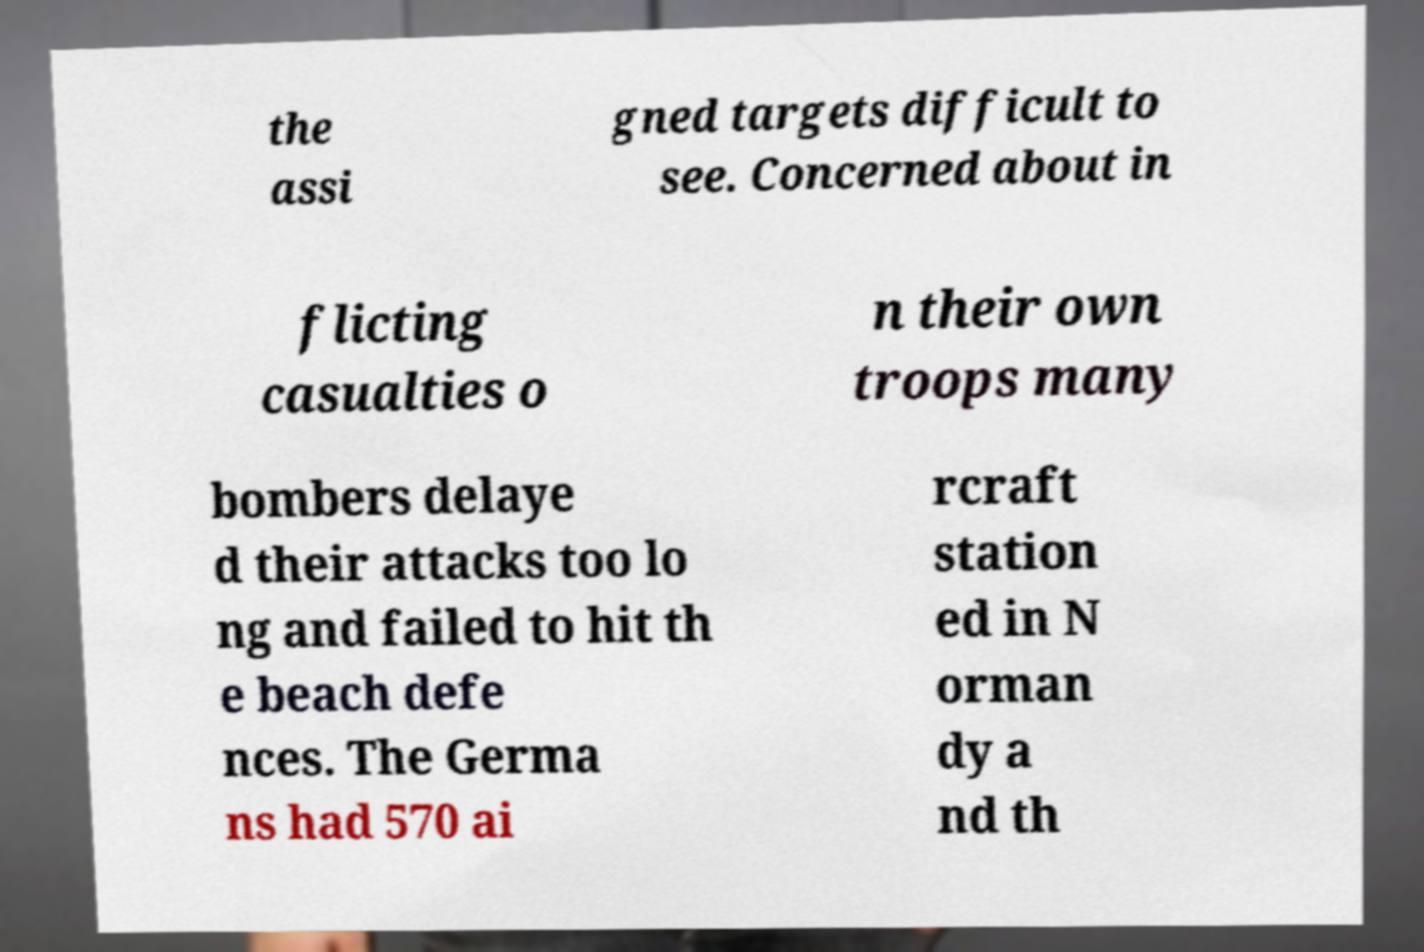Please identify and transcribe the text found in this image. the assi gned targets difficult to see. Concerned about in flicting casualties o n their own troops many bombers delaye d their attacks too lo ng and failed to hit th e beach defe nces. The Germa ns had 570 ai rcraft station ed in N orman dy a nd th 